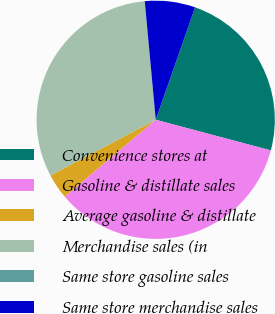Convert chart to OTSL. <chart><loc_0><loc_0><loc_500><loc_500><pie_chart><fcel>Convenience stores at<fcel>Gasoline & distillate sales<fcel>Average gasoline & distillate<fcel>Merchandise sales (in<fcel>Same store gasoline sales<fcel>Same store merchandise sales<nl><fcel>23.78%<fcel>34.69%<fcel>3.42%<fcel>31.27%<fcel>0.01%<fcel>6.83%<nl></chart> 